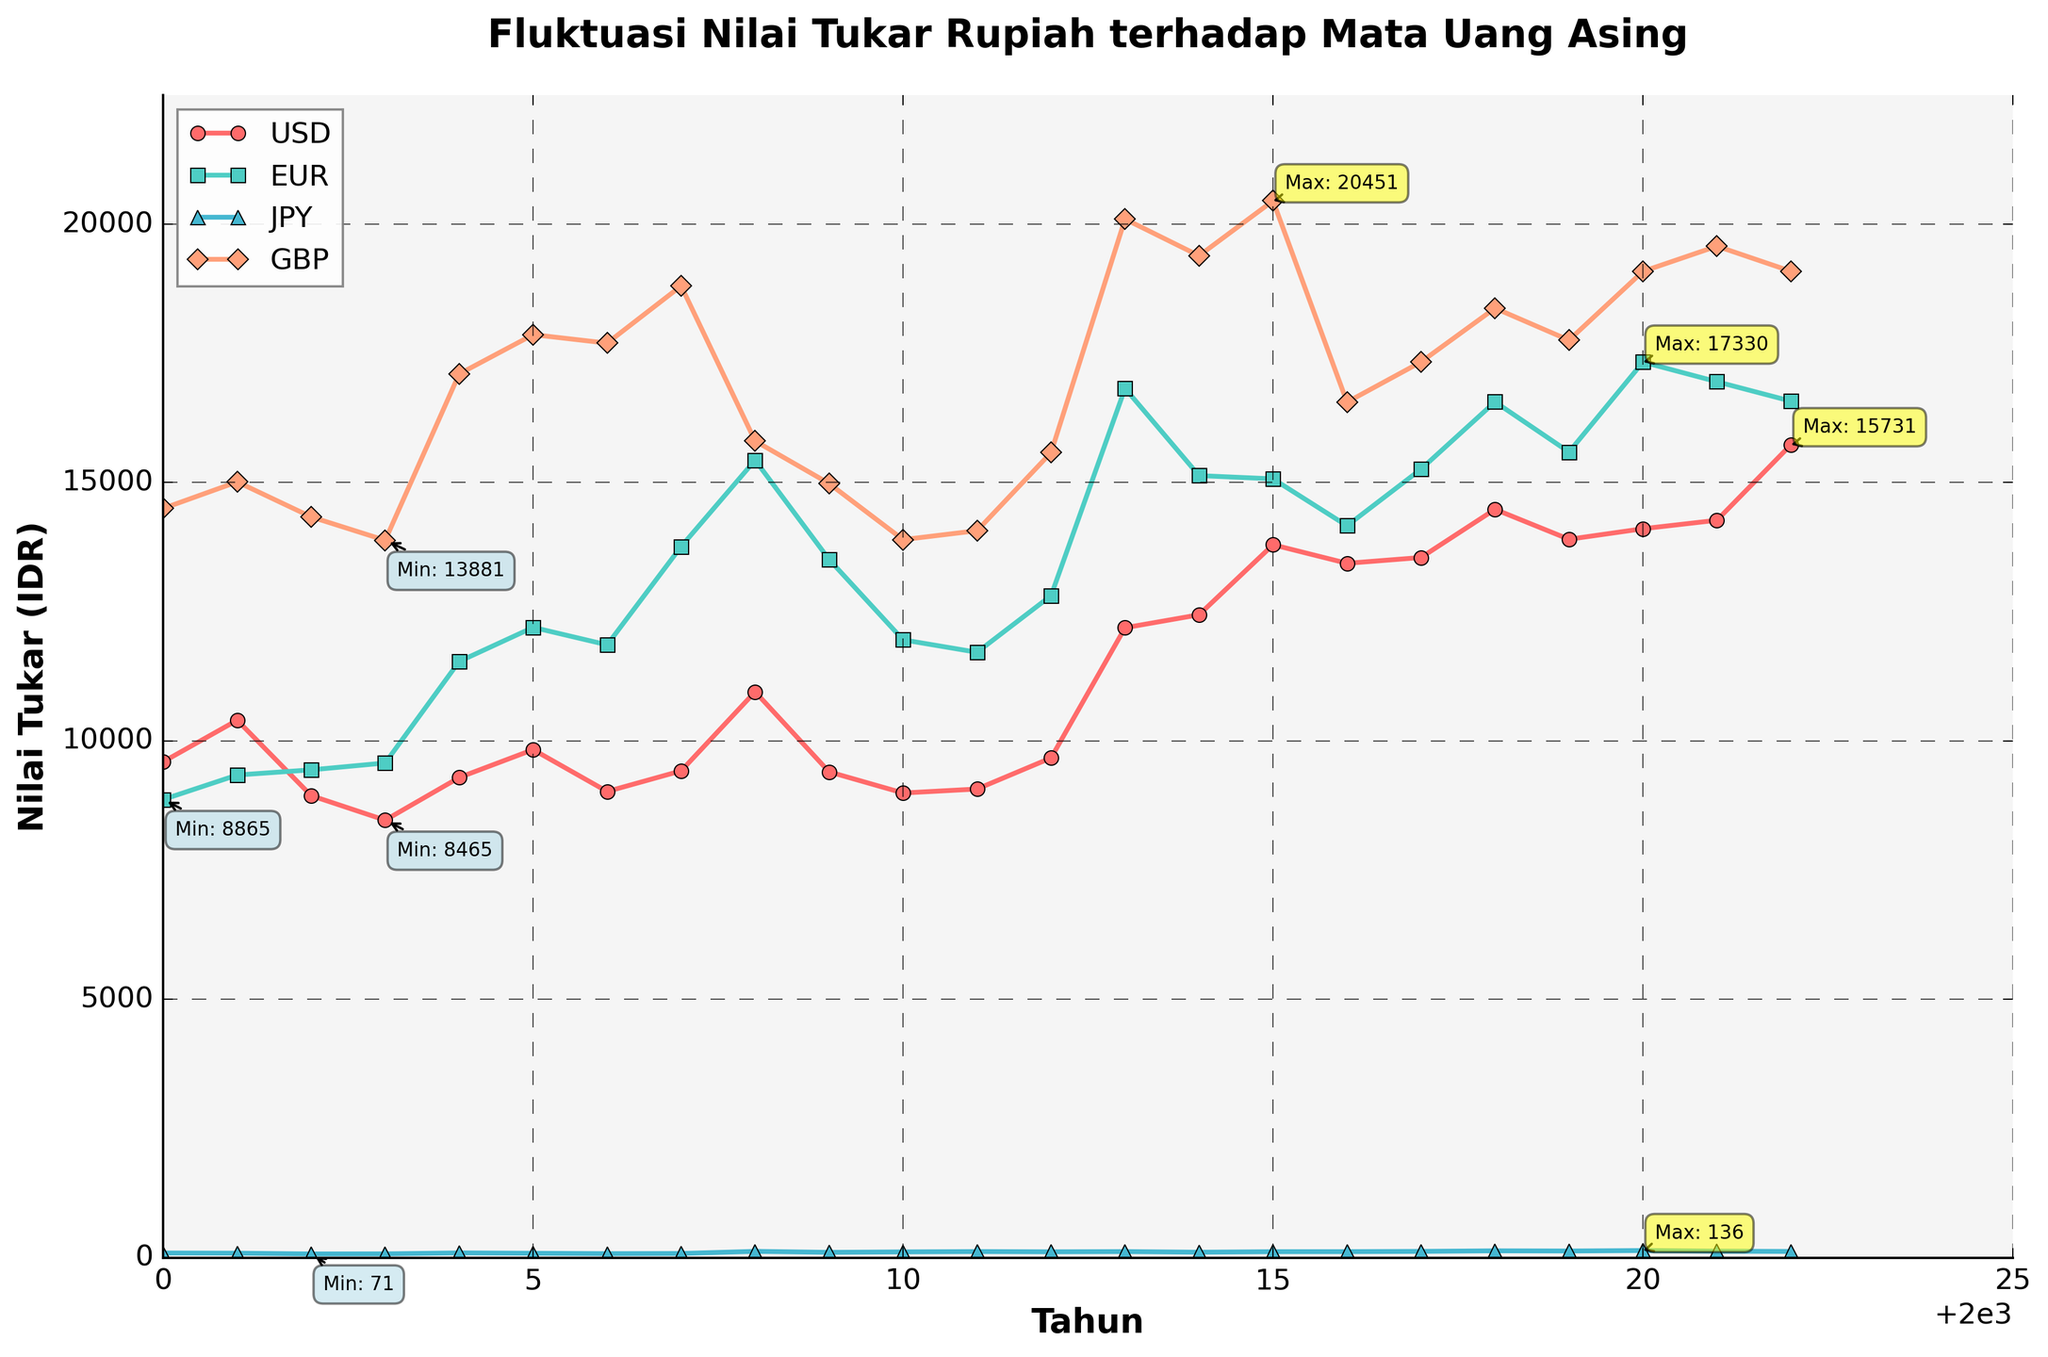What year's IDR/USD exchange rate saw the highest value? The IDR/USD exchange rate saw the highest value in the year when the annotated maximum value is shown on the figure.
Answer: 2022 Which currency's exchange rate with IDR was the most stable from 2000 to 2022? By examining the trends in the chart, the most stable exchange rate would be the one with the least fluctuations (i.e., smallest peaks and troughs).
Answer: JPY Between 2000 and 2022, in which year did all four currencies (USD, EUR, JPY, GBP) have their highest exchange rates simultaneously? Check the annotations for the highest values of each currency and see if there’s a common year among all annotations for their maxima.
Answer: No such year Which had a greater increase from 2000 to 2022: the IDR/USD or the IDR/EUR exchange rate? Subtract the 2000 values from the 2022 values for both IDR/USD and IDR/EUR and compare the differences. IDR/USD increase: 15731 - 9595, IDR/EUR increase: 16574 - 8865
Answer: IDR/USD What was the approximate average IDR/GBP exchange rate between 2010 and 2020? Sum the yearly values for IDR/GBP from 2010 to 2020 and divide by the number of years (i.e., 11 years). (13894 + 14067 + 15579 + 20097 + 19388 + 20451 + 16555 + 17332 + 18373 + 17754 + 19085) / 11 = 17486.3
Answer: 17486.3 Among the four currencies, which had the lowest minimum value against IDR and in which year? Look at the annotations for the minimum value. The currency with the smallest annotated minimum value is the answer, and the corresponding year is determined by that annotation.
Answer: JPY in 2002 In which years did the IDR/USD exchange rate fall below 9000? Identify the plotted data points for IDR/USD that are below the value of 9000 and list those years.
Answer: 2002, 2003, 2010 